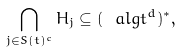Convert formula to latex. <formula><loc_0><loc_0><loc_500><loc_500>\bigcap _ { j \in S ( t ) ^ { c } } H _ { j } \subseteq ( \ a l g t ^ { d } ) ^ { * } ,</formula> 